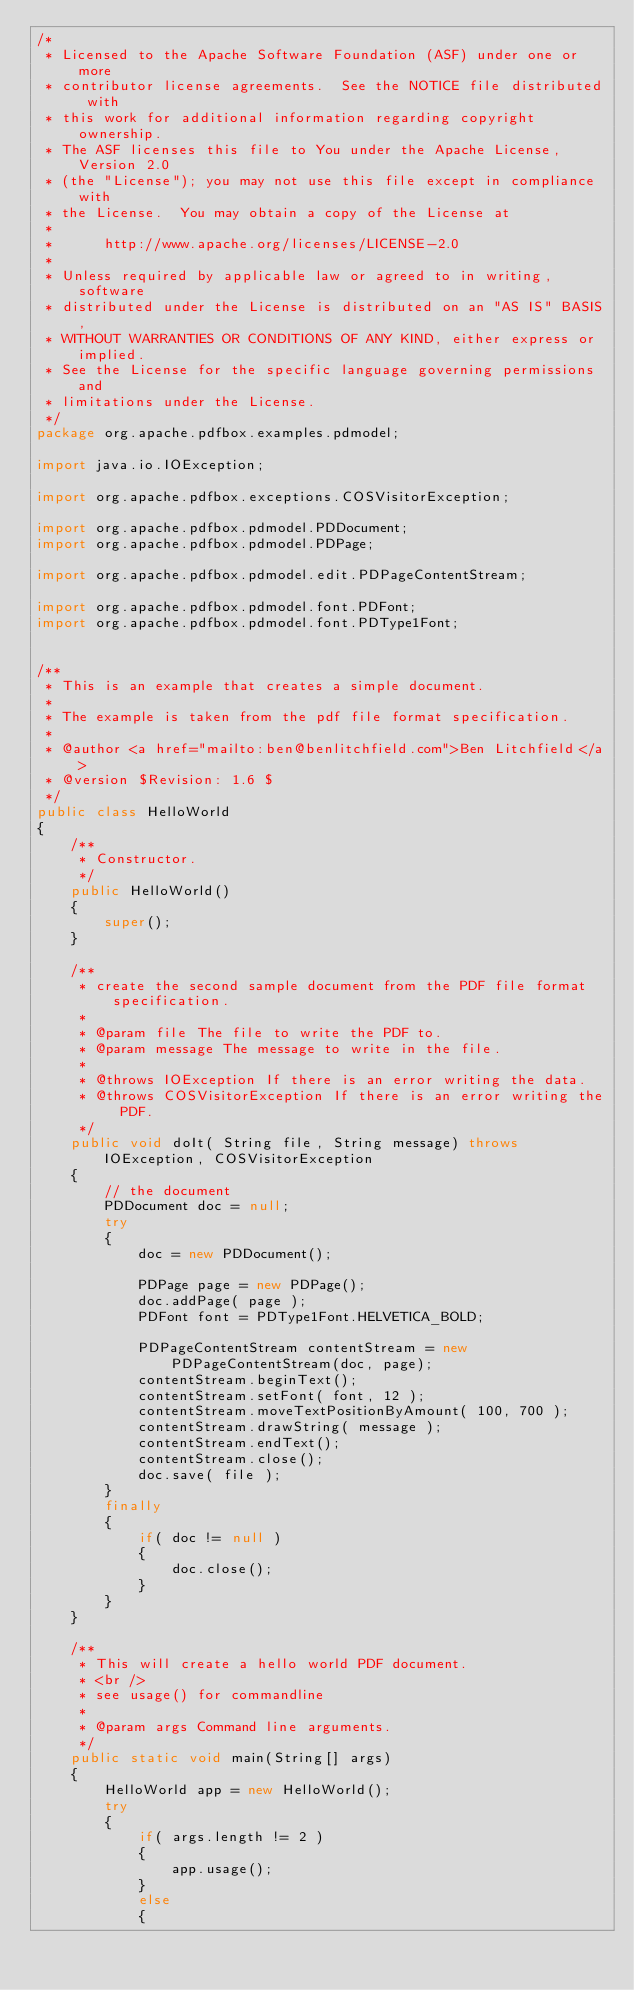<code> <loc_0><loc_0><loc_500><loc_500><_Java_>/*
 * Licensed to the Apache Software Foundation (ASF) under one or more
 * contributor license agreements.  See the NOTICE file distributed with
 * this work for additional information regarding copyright ownership.
 * The ASF licenses this file to You under the Apache License, Version 2.0
 * (the "License"); you may not use this file except in compliance with
 * the License.  You may obtain a copy of the License at
 *
 *      http://www.apache.org/licenses/LICENSE-2.0
 *
 * Unless required by applicable law or agreed to in writing, software
 * distributed under the License is distributed on an "AS IS" BASIS,
 * WITHOUT WARRANTIES OR CONDITIONS OF ANY KIND, either express or implied.
 * See the License for the specific language governing permissions and
 * limitations under the License.
 */
package org.apache.pdfbox.examples.pdmodel;

import java.io.IOException;

import org.apache.pdfbox.exceptions.COSVisitorException;

import org.apache.pdfbox.pdmodel.PDDocument;
import org.apache.pdfbox.pdmodel.PDPage;

import org.apache.pdfbox.pdmodel.edit.PDPageContentStream;

import org.apache.pdfbox.pdmodel.font.PDFont;
import org.apache.pdfbox.pdmodel.font.PDType1Font;


/**
 * This is an example that creates a simple document.
 *
 * The example is taken from the pdf file format specification.
 *
 * @author <a href="mailto:ben@benlitchfield.com">Ben Litchfield</a>
 * @version $Revision: 1.6 $
 */
public class HelloWorld
{
    /**
     * Constructor.
     */
    public HelloWorld()
    {
        super();
    }

    /**
     * create the second sample document from the PDF file format specification.
     *
     * @param file The file to write the PDF to.
     * @param message The message to write in the file.
     *
     * @throws IOException If there is an error writing the data.
     * @throws COSVisitorException If there is an error writing the PDF.
     */
    public void doIt( String file, String message) throws IOException, COSVisitorException
    {
        // the document
        PDDocument doc = null;
        try
        {
            doc = new PDDocument();

            PDPage page = new PDPage();
            doc.addPage( page );
            PDFont font = PDType1Font.HELVETICA_BOLD;

            PDPageContentStream contentStream = new PDPageContentStream(doc, page);
            contentStream.beginText();
            contentStream.setFont( font, 12 );
            contentStream.moveTextPositionByAmount( 100, 700 );
            contentStream.drawString( message );
            contentStream.endText();
            contentStream.close();
            doc.save( file );
        }
        finally
        {
            if( doc != null )
            {
                doc.close();
            }
        }
    }

    /**
     * This will create a hello world PDF document.
     * <br />
     * see usage() for commandline
     *
     * @param args Command line arguments.
     */
    public static void main(String[] args)
    {
        HelloWorld app = new HelloWorld();
        try
        {
            if( args.length != 2 )
            {
                app.usage();
            }
            else
            {</code> 